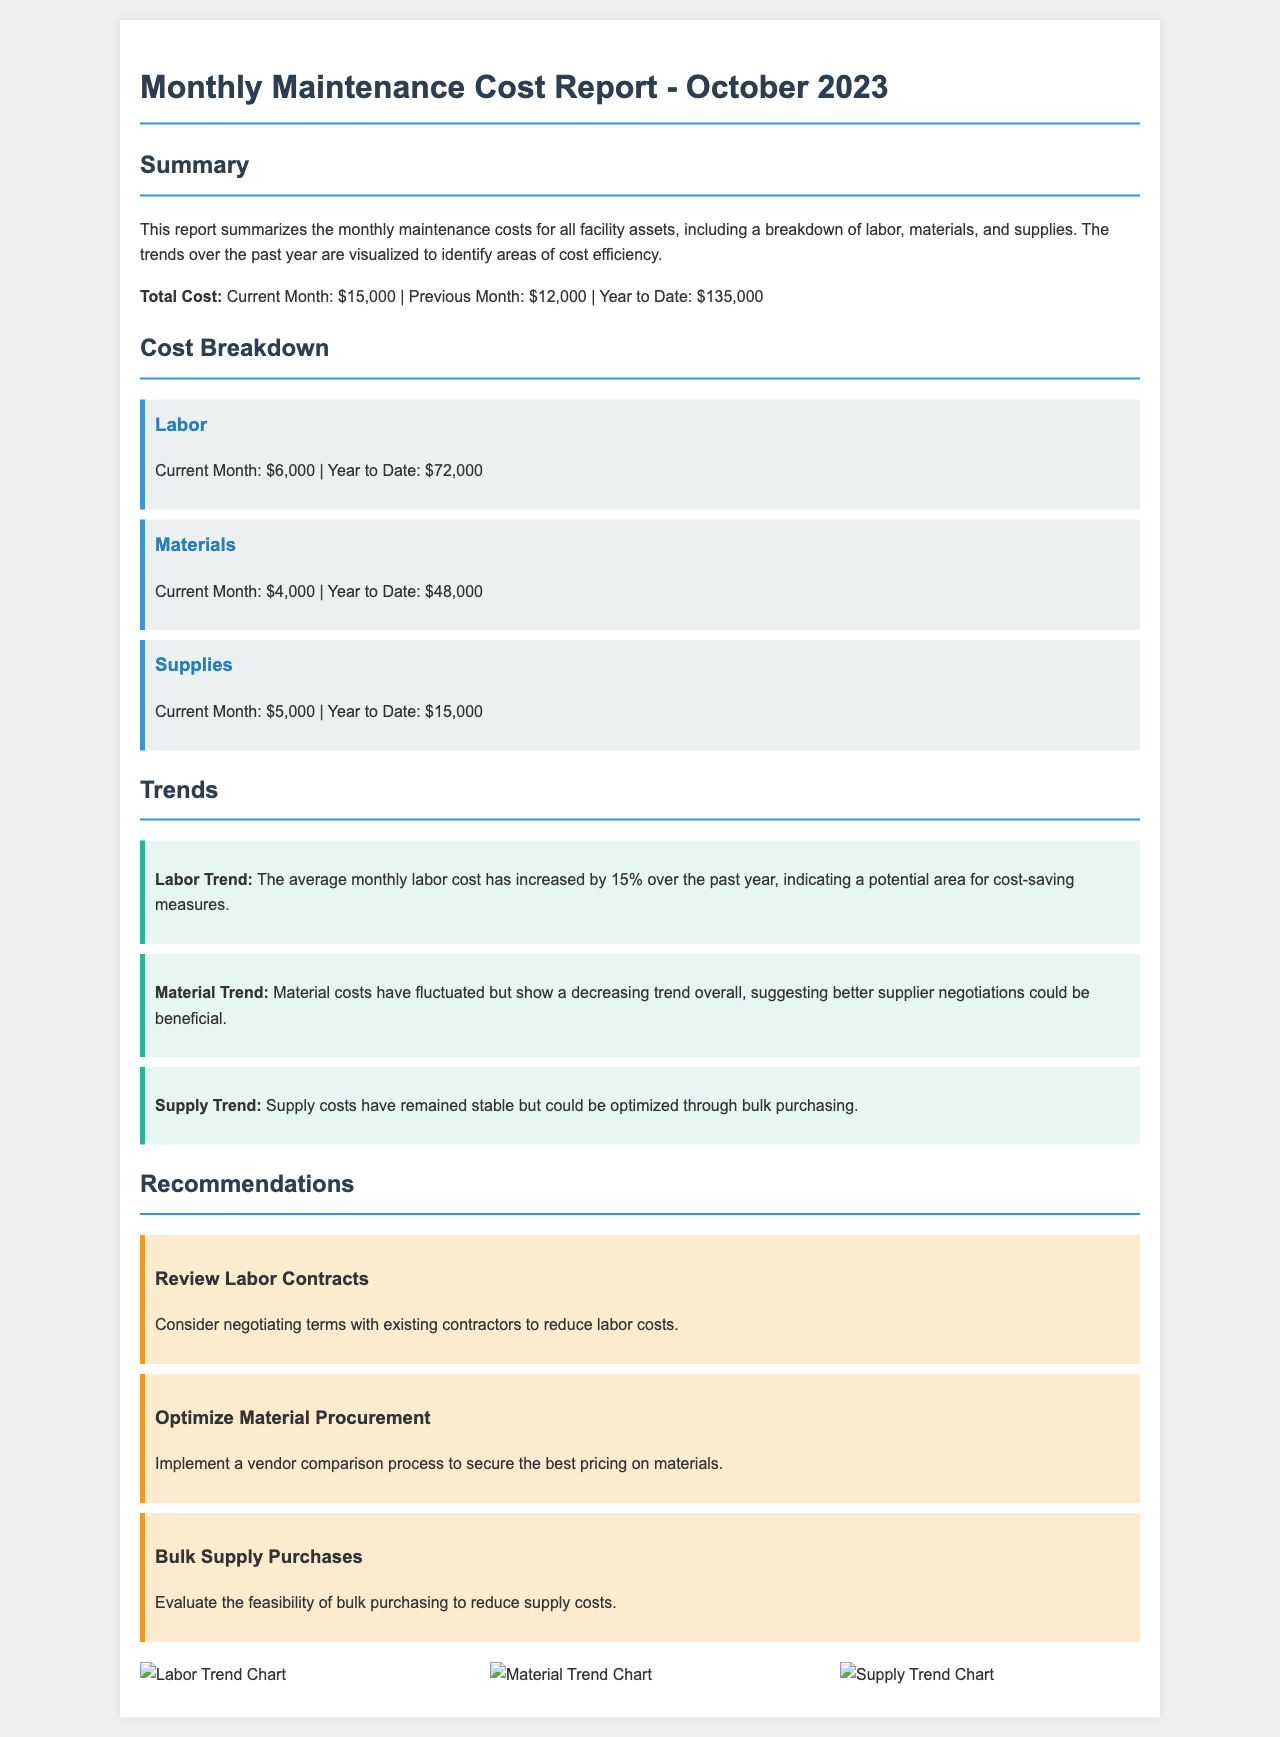What is the total cost for the current month? The total cost for the current month is indicated in the summary section.
Answer: $15,000 What was the labor cost for the year to date? The labor cost for the year to date is found in the cost breakdown section.
Answer: $72,000 What is the trend indicated for material costs? The document describes the material trend in the trends section, suggesting better supplier negotiations could be beneficial.
Answer: Decreasing trend What is the percentage increase in average monthly labor cost over the past year? The percentage increase in average monthly labor cost is stated in the trends section.
Answer: 15% How much did supplies cost in the current month? The current month supply cost is provided in the cost breakdown section.
Answer: $5,000 What is one recommendation given in the report? The recommendations section provides specific suggestions, and one example is asked for here.
Answer: Review Labor Contracts What trends are visualized in the report? The report includes visualizations for different types of costs, which are specified in the visuals section.
Answer: Labor, Material, Supply What is the year-to-date cost for materials? The year-to-date cost for materials can be found in the cost breakdown section.
Answer: $48,000 What visualizations are included in the report? The visuals section lists the types of trend charts presented.
Answer: Labor Trend Chart, Material Trend Chart, Supply Trend Chart 